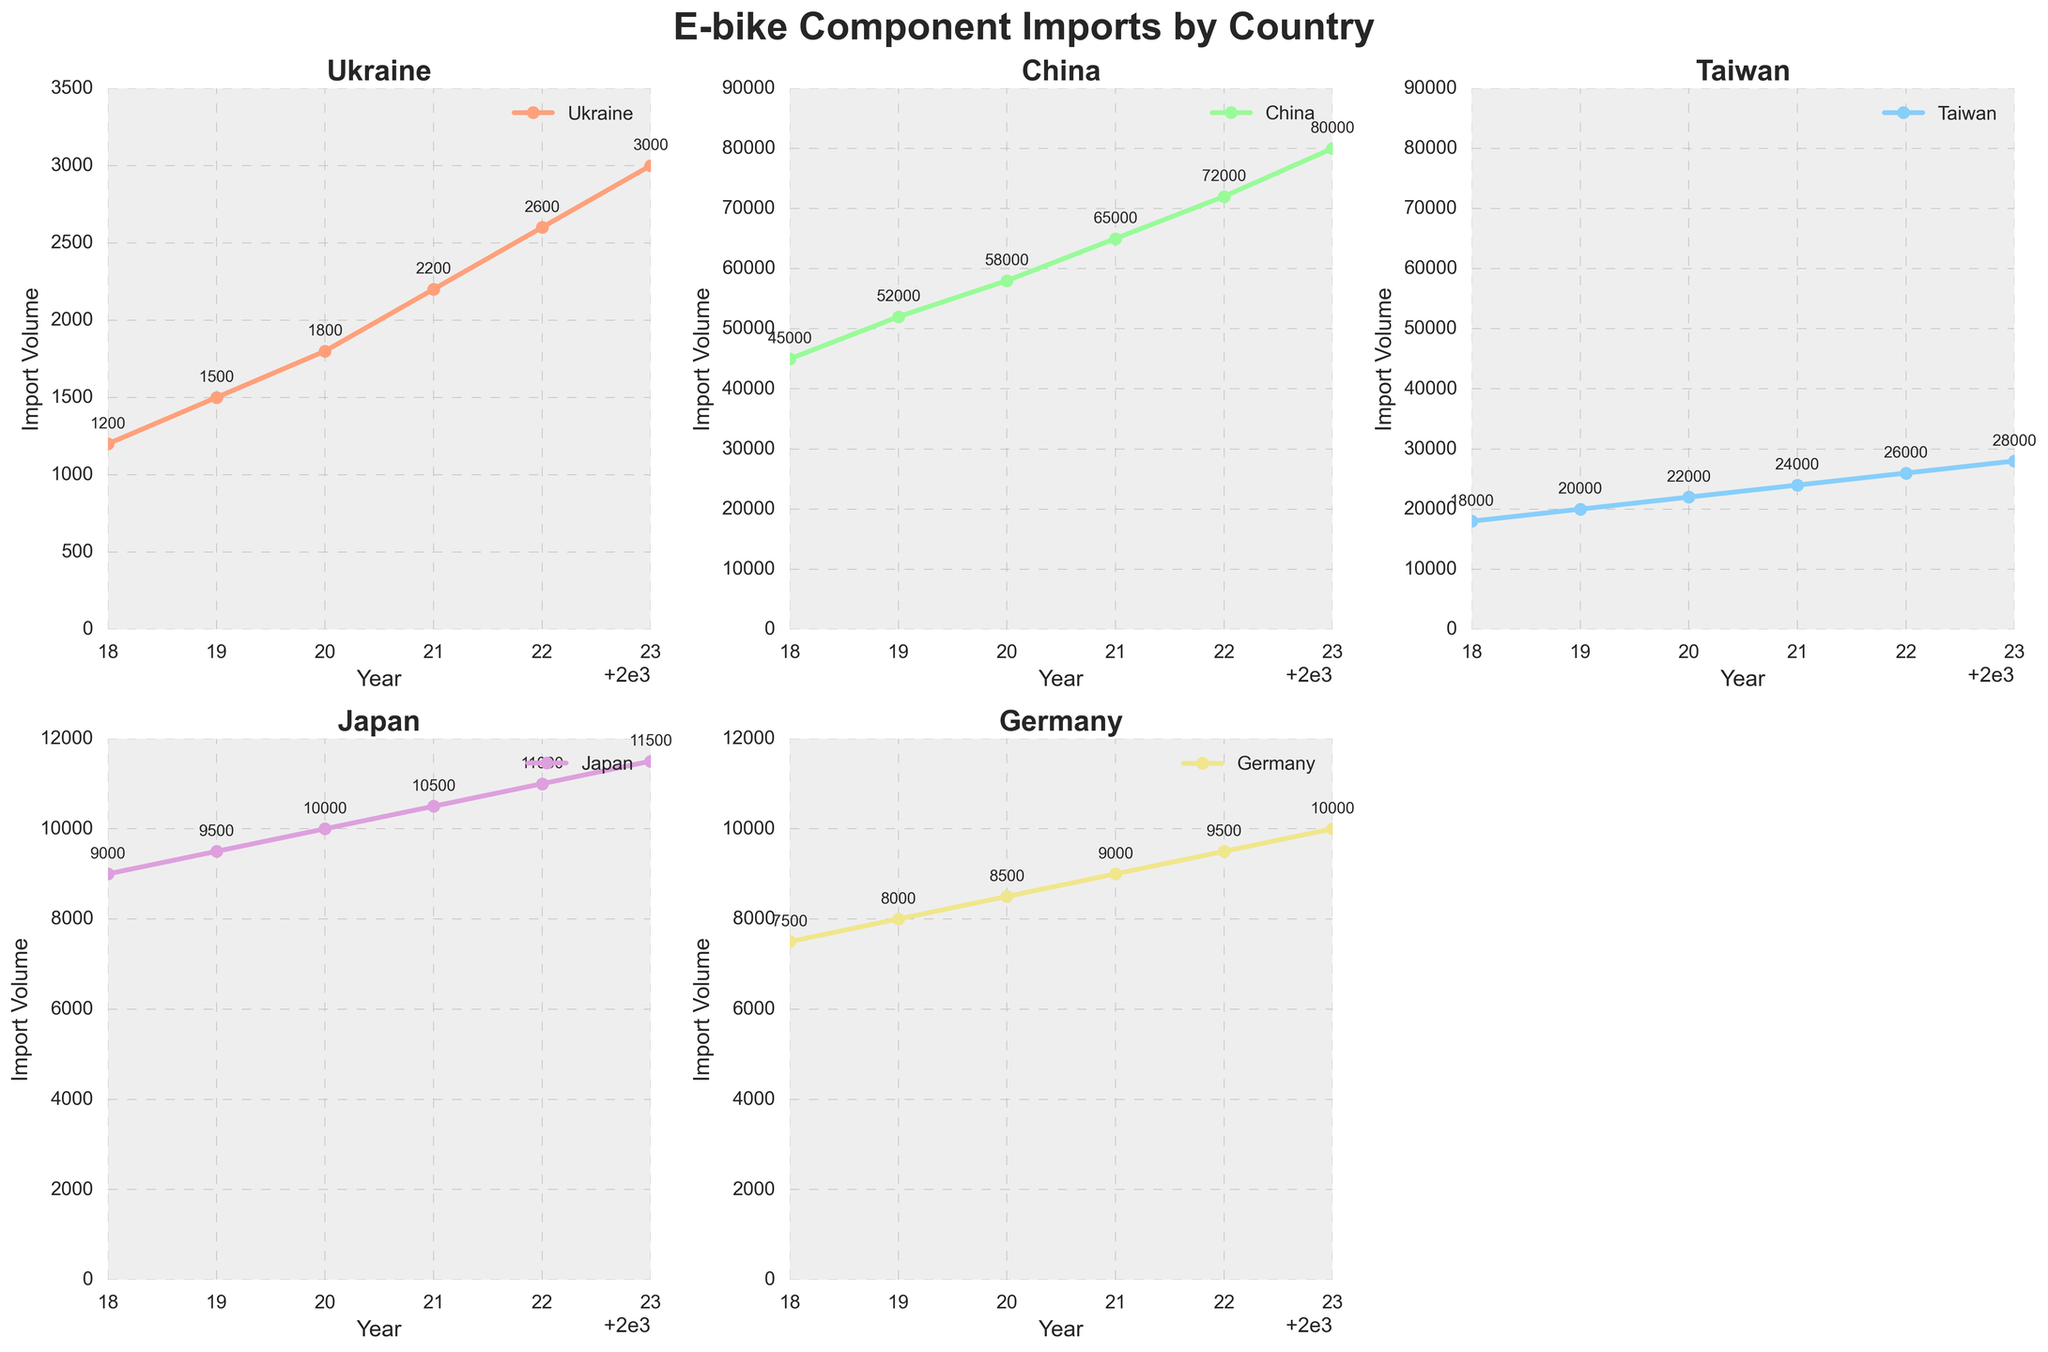Which country had the highest import volume in 2023? To answer this, look at the import volumes for each country in 2023. China has the highest import volume at 80,000 units.
Answer: China What was the average import volume of Japan over the years shown? Add the import volumes of Japan from 2018 to 2023 (9000 + 9500 + 10000 + 10500 + 11000 + 11500) then divide by the number of years, which is 6: (9000 + 9500 + 10000 + 10500 + 11000 + 11500) / 6 = 10,083.33
Answer: 10,083.33 By how much did the import volume of Ukraine increase from 2018 to 2023? Subtract the 2018 import volume of Ukraine from the 2023 import volume: 3000 (2023) - 1200 (2018) = 1800
Answer: 1800 Which country had the smallest range of import volumes from 2018 to 2023? Calculate the range for each country and find the smallest one:
Ukraine: 3000 - 1200 = 1800
China: 80000 - 45000 = 35000
Taiwan: 28000 - 18000 = 10000
Japan: 11500 - 9000 = 2500
Germany: 10000 - 7500 = 2500
Both Japan and Germany have the smallest range of 2500.
Answer: Japan and Germany In which year did Taiwan's import volume surpass 20,000 units for the first time? Look at the plot for Taiwan. The import volume surpasses 20,000 units in 2020.
Answer: 2020 Compare the trends for Ukraine and Germany from 2018 to 2023. Which country had the steeper growth in import volumes? Calculate the increase in import volume for both countries:
Ukraine: 3000 (2023) - 1200 (2018) = 1800
Germany: 10000 (2023) - 7500 (2018) = 2500
Next, compare the increases relative to their starting values. Ukraine's growth (1800/1200) has a steeper relative increase compared to Germany's growth (2500/7500).
Answer: Ukraine How many times larger were China's imports compared to Ukraine's in 2022? Divide China's import volume by Ukraine's for 2022: 72000 (China) / 2600 (Ukraine) = 27.69
Answer: 27.69 What is the difference between China and Taiwan's import volumes in 2021? Subtract Taiwan's import volume from China's in 2021: 65000 - 24000 = 41000
Answer: 41,000 